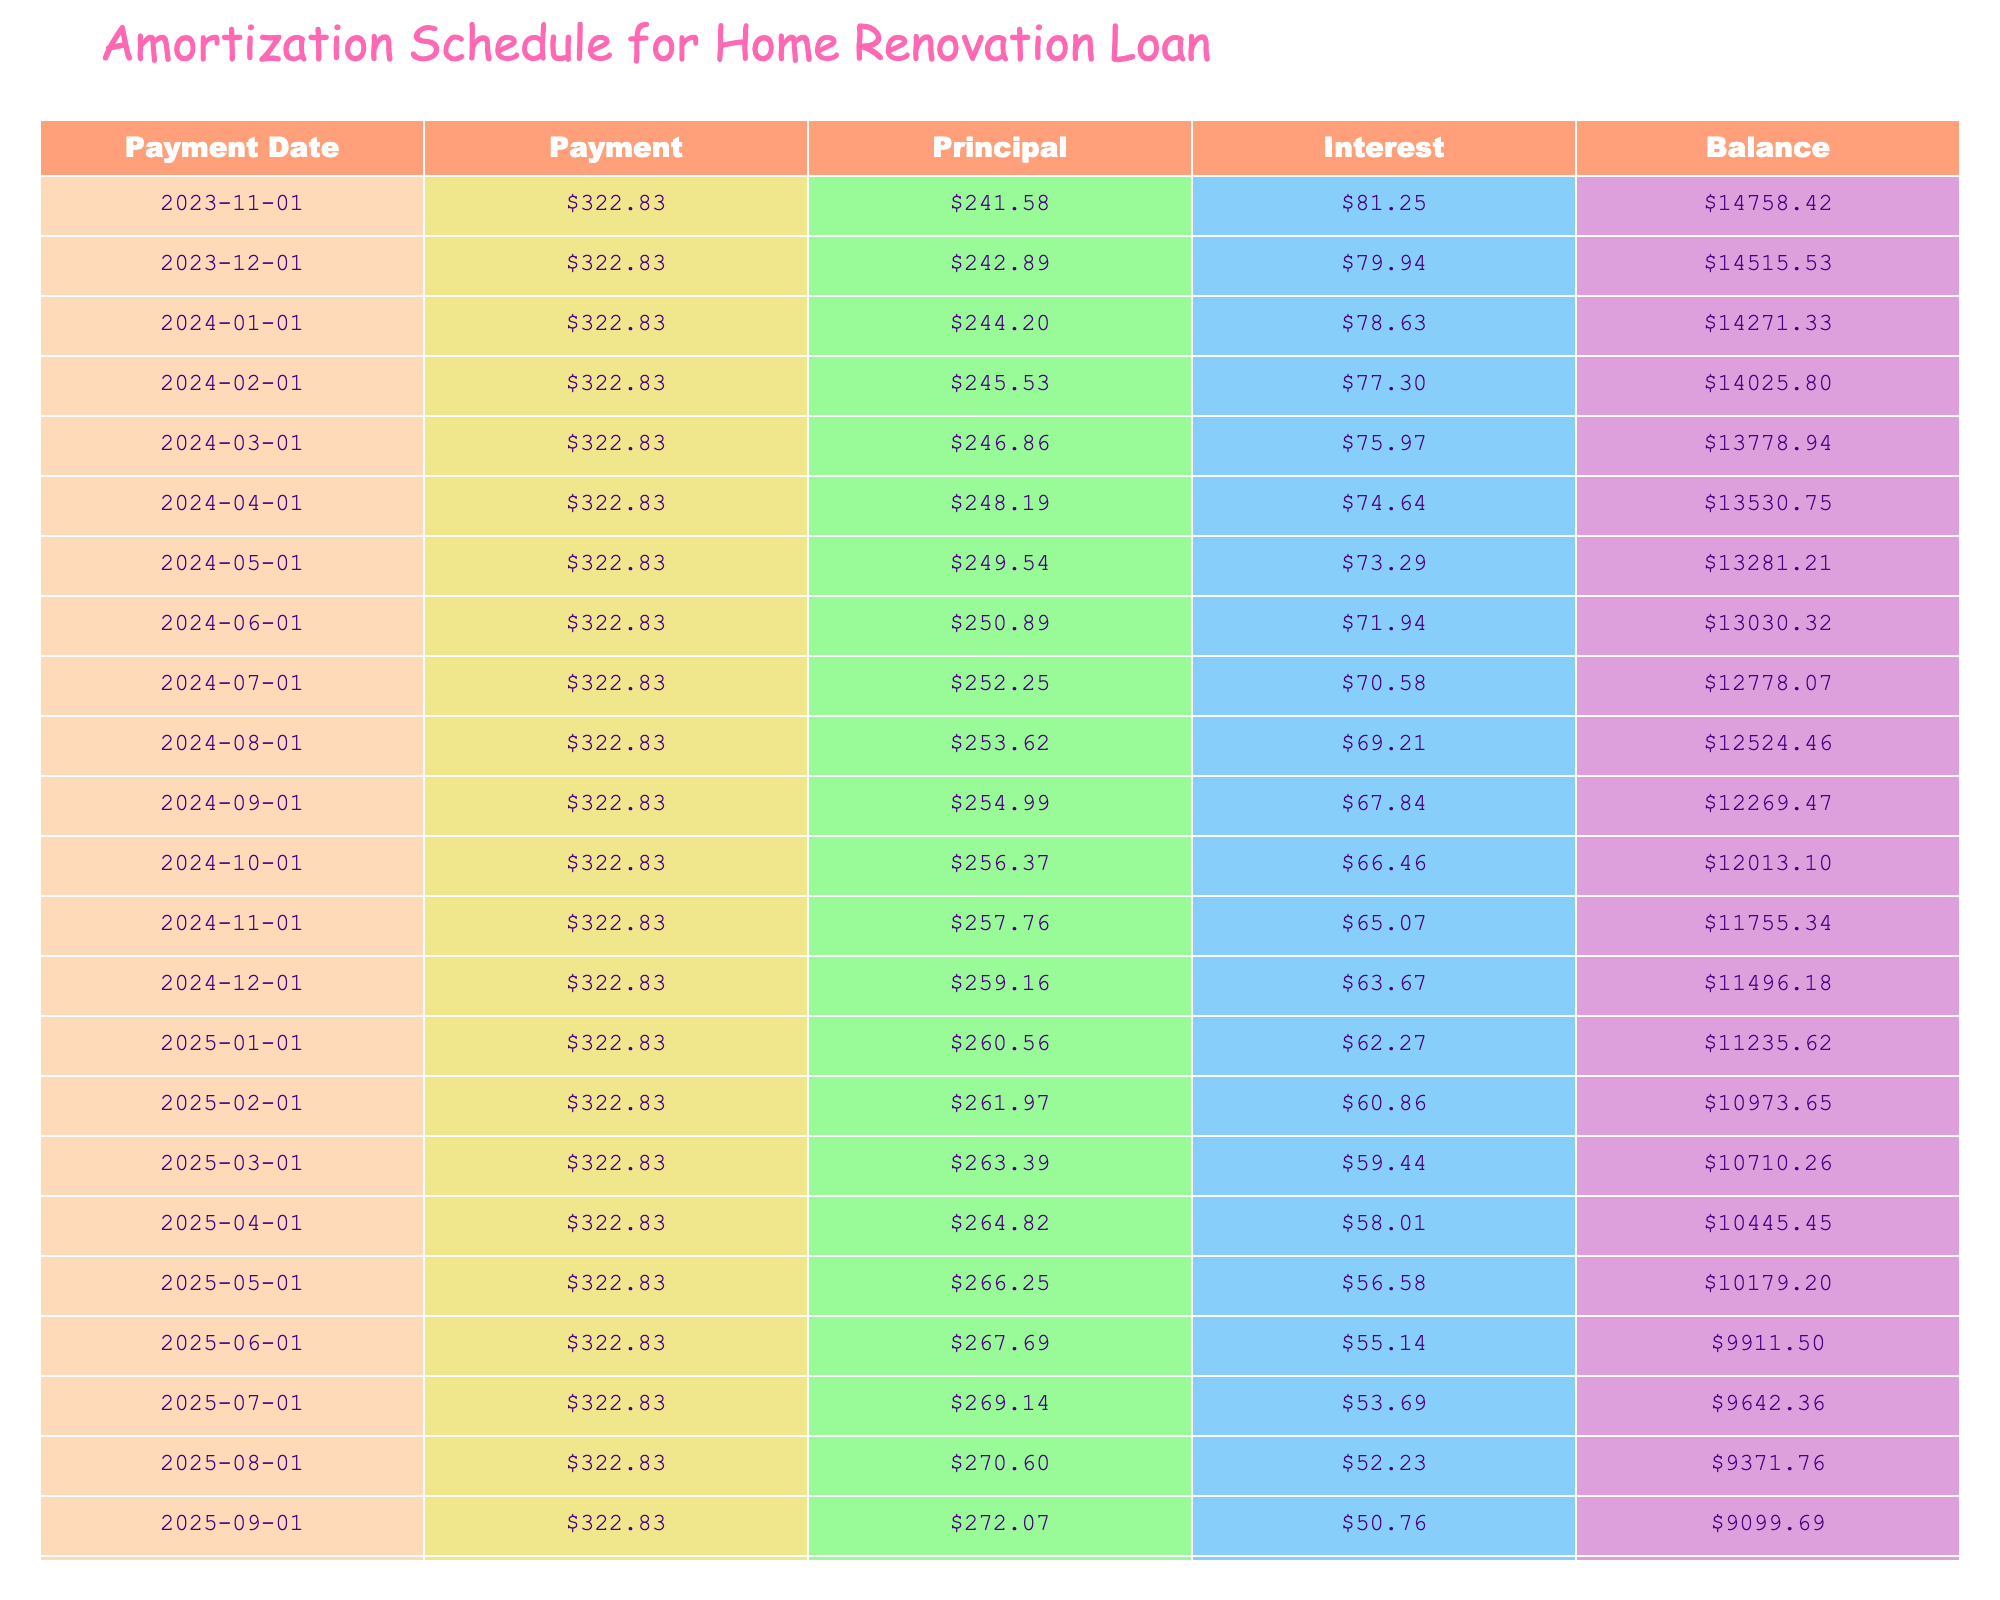What is the total payment over the life of the loan? The total payment is explicitly listed in the table under "Total Payment," which shows 19369.80.
Answer: 19369.80 What is the monthly payment for the loan? The monthly payment is provided in the "Monthly Payment" column, which indicates 322.83.
Answer: 322.83 How much total interest will be paid by the end of the loan term? The total interest is found in the "Total Interest" column, displaying an amount of 4369.80.
Answer: 4369.80 What is the balance after the first month? To find the balance after the first month, we start with the loan amount of 15000 and subtract the principal payment for the first month. The first month's interest would be 15000 * (6.5/100/12), which equals about 81.25. Therefore, the principal payment would be 322.83 - 81.25 = 241.58 and the new balance is 15000 - 241.58, which equals 14758.42.
Answer: 14758.42 Will the total interest paid exceed 4000 by the end of the loan term? Yes, the total interest listed in the table is 4369.80, which is greater than 4000.
Answer: Yes What will the balance be after the third payment? After the third payment, we can calculate the interest for the second and third months. The balance after the first month is 14758.42. The second month's interest is 14758.42 * (6.5/100/12) = 79.72. The second month's principal payment is 322.83 - 79.72 = 243.11 and the remaining balance is 14758.42 - 243.11 = 14515.31. For the third month, the interest is 14515.31 * (6.5/100/12) = 78.40 and the principal is 322.83 - 78.40 = 244.43, resulting in a balance of 14515.31 - 244.43 = 14270.88.
Answer: 14270.88 What is the difference between the total payment and the total interest? To find the difference, subtract the total interest from the total payment. Total payment is 19369.80 and total interest is 4369.80, so the difference is 19369.80 - 4369.80 = 15000.
Answer: 15000 How much will be paid in principal in the last month? The final payment remains constant at 322.83. To determine the principal portion, we need the remaining balance just before the last payment. The last balance can be estimated (but not calculated here), and substituting the balance into the formula for finding interest will yield the interest portion. Assuming the approximate interest before the last payment is small, the principal portion is roughly 322.83 - the final interest.
Answer: It varies per month but generally close to 300+ 